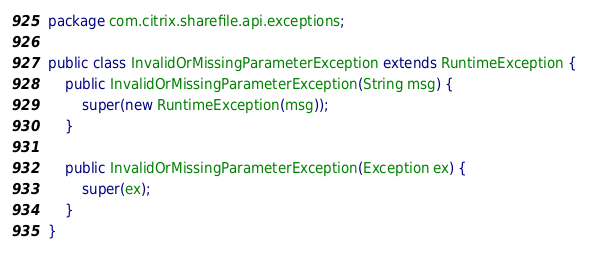<code> <loc_0><loc_0><loc_500><loc_500><_Java_>package com.citrix.sharefile.api.exceptions;

public class InvalidOrMissingParameterException extends RuntimeException {
    public InvalidOrMissingParameterException(String msg) {
        super(new RuntimeException(msg));
    }

    public InvalidOrMissingParameterException(Exception ex) {
        super(ex);
    }
}</code> 